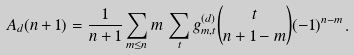<formula> <loc_0><loc_0><loc_500><loc_500>A _ { d } ( n + 1 ) = \frac { 1 } { n + 1 } \sum _ { m \leq n } m \, \sum _ { t } g _ { m , t } ^ { ( d ) } { t \choose n + 1 - m } ( - 1 ) ^ { n - m } \, .</formula> 